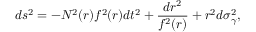Convert formula to latex. <formula><loc_0><loc_0><loc_500><loc_500>d s ^ { 2 } = - N ^ { 2 } ( r ) f ^ { 2 } ( r ) d t ^ { 2 } + \frac { d r ^ { 2 } } { f ^ { 2 } ( r ) } + r ^ { 2 } d \sigma _ { \gamma } ^ { 2 } ,</formula> 